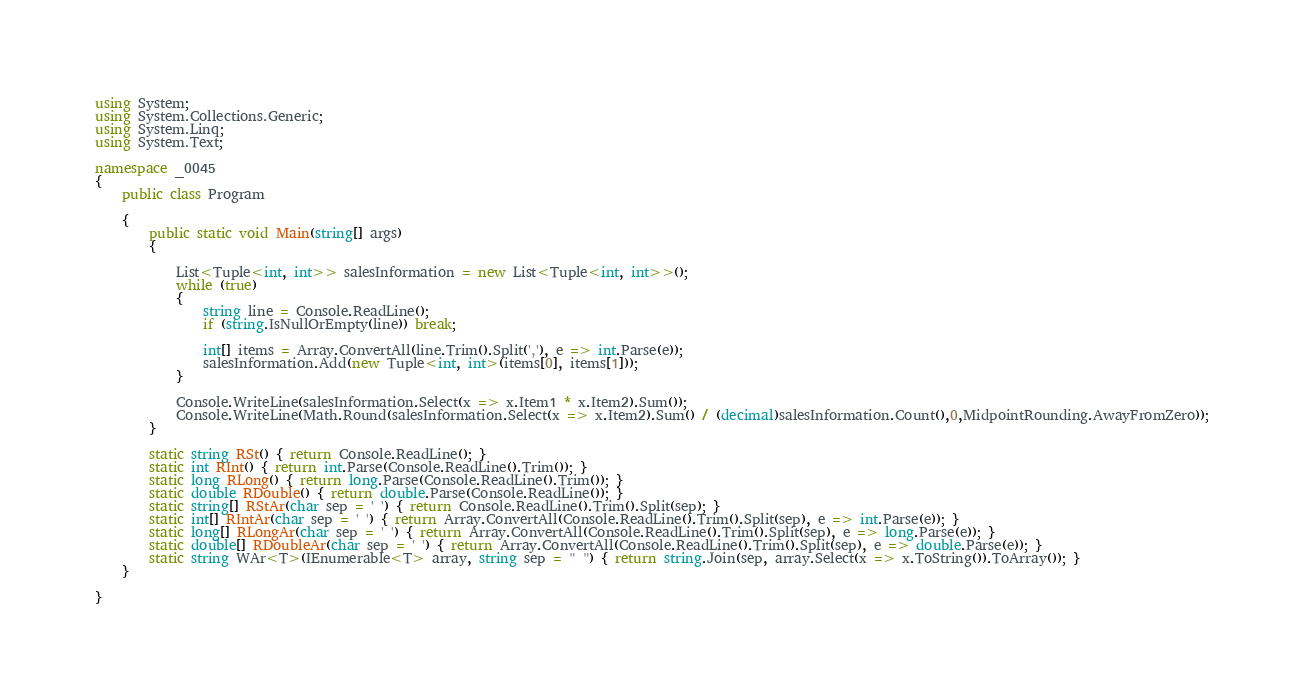<code> <loc_0><loc_0><loc_500><loc_500><_C#_>using System;
using System.Collections.Generic;
using System.Linq;
using System.Text;

namespace _0045
{
    public class Program

    {
        public static void Main(string[] args)
        {

            List<Tuple<int, int>> salesInformation = new List<Tuple<int, int>>();
            while (true)
            {
                string line = Console.ReadLine();
                if (string.IsNullOrEmpty(line)) break;

                int[] items = Array.ConvertAll(line.Trim().Split(','), e => int.Parse(e));
                salesInformation.Add(new Tuple<int, int>(items[0], items[1]));
            }

            Console.WriteLine(salesInformation.Select(x => x.Item1 * x.Item2).Sum());
            Console.WriteLine(Math.Round(salesInformation.Select(x => x.Item2).Sum() / (decimal)salesInformation.Count(),0,MidpointRounding.AwayFromZero));
        }

        static string RSt() { return Console.ReadLine(); }
        static int RInt() { return int.Parse(Console.ReadLine().Trim()); }
        static long RLong() { return long.Parse(Console.ReadLine().Trim()); }
        static double RDouble() { return double.Parse(Console.ReadLine()); }
        static string[] RStAr(char sep = ' ') { return Console.ReadLine().Trim().Split(sep); }
        static int[] RIntAr(char sep = ' ') { return Array.ConvertAll(Console.ReadLine().Trim().Split(sep), e => int.Parse(e)); }
        static long[] RLongAr(char sep = ' ') { return Array.ConvertAll(Console.ReadLine().Trim().Split(sep), e => long.Parse(e)); }
        static double[] RDoubleAr(char sep = ' ') { return Array.ConvertAll(Console.ReadLine().Trim().Split(sep), e => double.Parse(e)); }
        static string WAr<T>(IEnumerable<T> array, string sep = " ") { return string.Join(sep, array.Select(x => x.ToString()).ToArray()); }
    }

}

</code> 